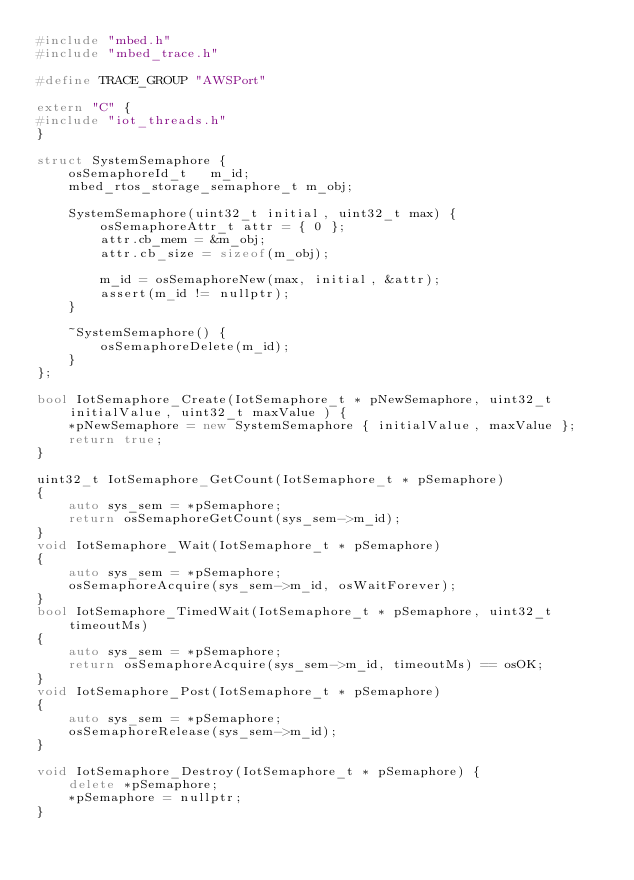<code> <loc_0><loc_0><loc_500><loc_500><_C++_>#include "mbed.h"
#include "mbed_trace.h"

#define TRACE_GROUP "AWSPort"

extern "C" {
#include "iot_threads.h"
}

struct SystemSemaphore {
    osSemaphoreId_t   m_id;
    mbed_rtos_storage_semaphore_t m_obj;

    SystemSemaphore(uint32_t initial, uint32_t max) {
        osSemaphoreAttr_t attr = { 0 };
        attr.cb_mem = &m_obj;
        attr.cb_size = sizeof(m_obj);

        m_id = osSemaphoreNew(max, initial, &attr);
        assert(m_id != nullptr);
    }

    ~SystemSemaphore() {
        osSemaphoreDelete(m_id);
    }
};

bool IotSemaphore_Create(IotSemaphore_t * pNewSemaphore, uint32_t initialValue, uint32_t maxValue ) {
    *pNewSemaphore = new SystemSemaphore { initialValue, maxValue };
    return true;
}

uint32_t IotSemaphore_GetCount(IotSemaphore_t * pSemaphore)
{
    auto sys_sem = *pSemaphore;
    return osSemaphoreGetCount(sys_sem->m_id);
}
void IotSemaphore_Wait(IotSemaphore_t * pSemaphore)
{
    auto sys_sem = *pSemaphore;
    osSemaphoreAcquire(sys_sem->m_id, osWaitForever);
}
bool IotSemaphore_TimedWait(IotSemaphore_t * pSemaphore, uint32_t timeoutMs)
{
    auto sys_sem = *pSemaphore;
    return osSemaphoreAcquire(sys_sem->m_id, timeoutMs) == osOK;
}
void IotSemaphore_Post(IotSemaphore_t * pSemaphore)
{
    auto sys_sem = *pSemaphore;
    osSemaphoreRelease(sys_sem->m_id);
}

void IotSemaphore_Destroy(IotSemaphore_t * pSemaphore) {
    delete *pSemaphore;
    *pSemaphore = nullptr;
}
</code> 